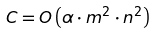Convert formula to latex. <formula><loc_0><loc_0><loc_500><loc_500>C = O \left ( \alpha \cdot m ^ { 2 } \cdot n ^ { 2 } \right )</formula> 